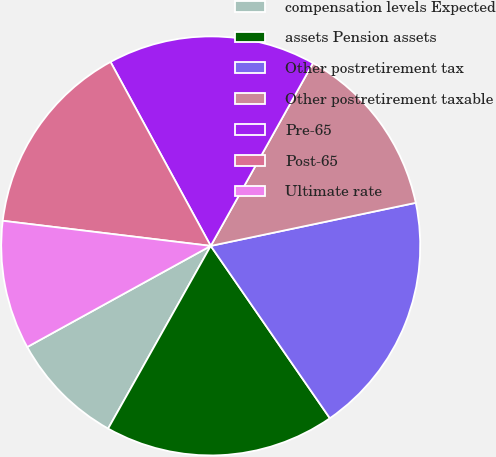Convert chart to OTSL. <chart><loc_0><loc_0><loc_500><loc_500><pie_chart><fcel>compensation levels Expected<fcel>assets Pension assets<fcel>Other postretirement tax<fcel>Other postretirement taxable<fcel>Pre-65<fcel>Post-65<fcel>Ultimate rate<nl><fcel>8.84%<fcel>17.77%<fcel>18.67%<fcel>13.59%<fcel>16.05%<fcel>15.15%<fcel>9.93%<nl></chart> 